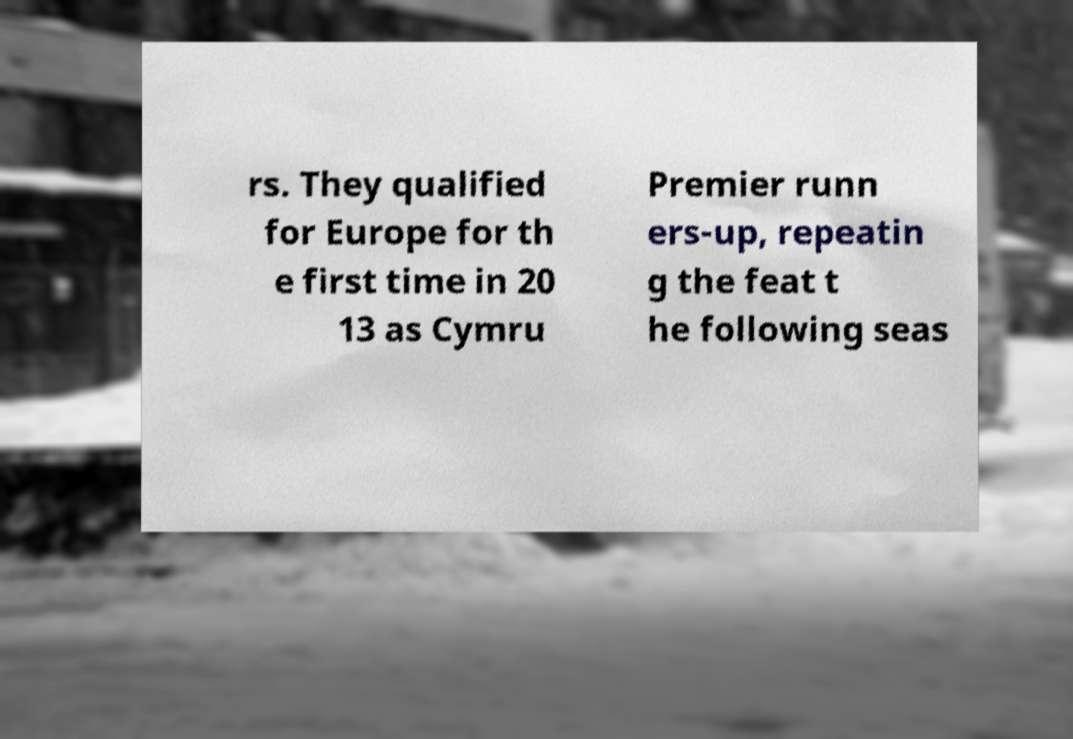Could you extract and type out the text from this image? rs. They qualified for Europe for th e first time in 20 13 as Cymru Premier runn ers-up, repeatin g the feat t he following seas 